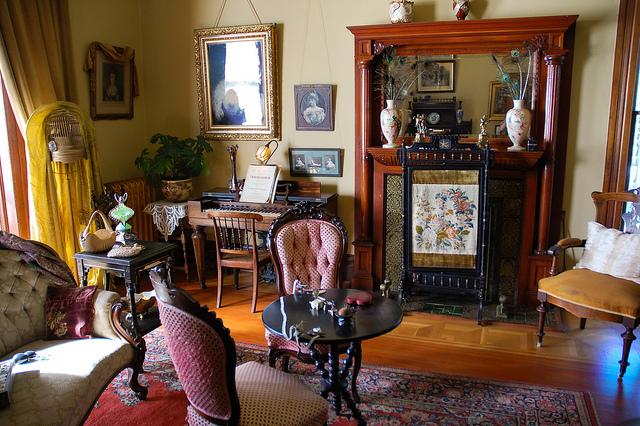What is the source of heat in this room?
Short answer required. Fireplace. Are these pieces of furniture modern?
Quick response, please. No. How many chairs are there?
Short answer required. 4. 